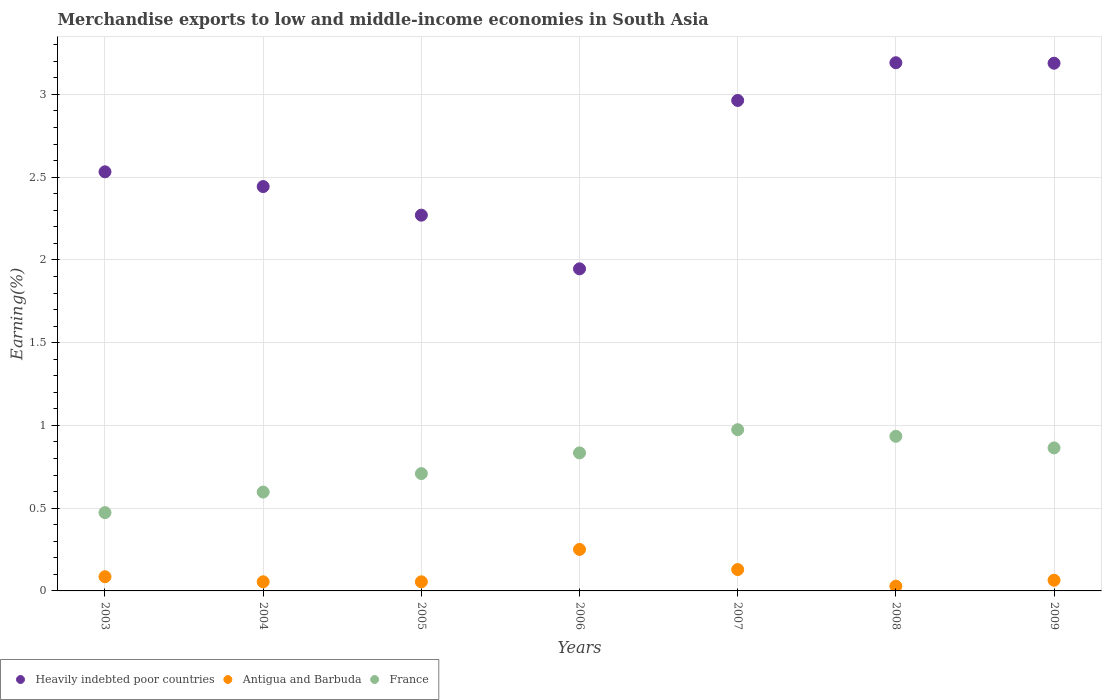How many different coloured dotlines are there?
Your answer should be compact. 3. Is the number of dotlines equal to the number of legend labels?
Your answer should be very brief. Yes. What is the percentage of amount earned from merchandise exports in Antigua and Barbuda in 2007?
Ensure brevity in your answer.  0.13. Across all years, what is the maximum percentage of amount earned from merchandise exports in Heavily indebted poor countries?
Ensure brevity in your answer.  3.19. Across all years, what is the minimum percentage of amount earned from merchandise exports in Antigua and Barbuda?
Provide a succinct answer. 0.03. In which year was the percentage of amount earned from merchandise exports in Antigua and Barbuda maximum?
Provide a succinct answer. 2006. In which year was the percentage of amount earned from merchandise exports in Heavily indebted poor countries minimum?
Offer a terse response. 2006. What is the total percentage of amount earned from merchandise exports in France in the graph?
Offer a very short reply. 5.39. What is the difference between the percentage of amount earned from merchandise exports in Antigua and Barbuda in 2004 and that in 2009?
Make the answer very short. -0.01. What is the difference between the percentage of amount earned from merchandise exports in France in 2004 and the percentage of amount earned from merchandise exports in Antigua and Barbuda in 2005?
Provide a short and direct response. 0.54. What is the average percentage of amount earned from merchandise exports in France per year?
Ensure brevity in your answer.  0.77. In the year 2006, what is the difference between the percentage of amount earned from merchandise exports in Heavily indebted poor countries and percentage of amount earned from merchandise exports in Antigua and Barbuda?
Offer a very short reply. 1.7. What is the ratio of the percentage of amount earned from merchandise exports in Antigua and Barbuda in 2003 to that in 2005?
Give a very brief answer. 1.56. Is the percentage of amount earned from merchandise exports in Heavily indebted poor countries in 2005 less than that in 2007?
Your response must be concise. Yes. Is the difference between the percentage of amount earned from merchandise exports in Heavily indebted poor countries in 2005 and 2007 greater than the difference between the percentage of amount earned from merchandise exports in Antigua and Barbuda in 2005 and 2007?
Offer a very short reply. No. What is the difference between the highest and the second highest percentage of amount earned from merchandise exports in Antigua and Barbuda?
Your answer should be very brief. 0.12. What is the difference between the highest and the lowest percentage of amount earned from merchandise exports in Heavily indebted poor countries?
Provide a short and direct response. 1.25. In how many years, is the percentage of amount earned from merchandise exports in Antigua and Barbuda greater than the average percentage of amount earned from merchandise exports in Antigua and Barbuda taken over all years?
Keep it short and to the point. 2. Is it the case that in every year, the sum of the percentage of amount earned from merchandise exports in Antigua and Barbuda and percentage of amount earned from merchandise exports in France  is greater than the percentage of amount earned from merchandise exports in Heavily indebted poor countries?
Your response must be concise. No. Is the percentage of amount earned from merchandise exports in Heavily indebted poor countries strictly greater than the percentage of amount earned from merchandise exports in France over the years?
Provide a short and direct response. Yes. How many dotlines are there?
Your response must be concise. 3. What is the difference between two consecutive major ticks on the Y-axis?
Provide a short and direct response. 0.5. Where does the legend appear in the graph?
Provide a short and direct response. Bottom left. How many legend labels are there?
Your answer should be compact. 3. What is the title of the graph?
Your answer should be compact. Merchandise exports to low and middle-income economies in South Asia. Does "Cayman Islands" appear as one of the legend labels in the graph?
Your answer should be compact. No. What is the label or title of the X-axis?
Provide a succinct answer. Years. What is the label or title of the Y-axis?
Offer a terse response. Earning(%). What is the Earning(%) in Heavily indebted poor countries in 2003?
Your answer should be compact. 2.53. What is the Earning(%) of Antigua and Barbuda in 2003?
Your answer should be compact. 0.09. What is the Earning(%) of France in 2003?
Offer a very short reply. 0.47. What is the Earning(%) in Heavily indebted poor countries in 2004?
Make the answer very short. 2.44. What is the Earning(%) in Antigua and Barbuda in 2004?
Your answer should be compact. 0.06. What is the Earning(%) of France in 2004?
Ensure brevity in your answer.  0.6. What is the Earning(%) of Heavily indebted poor countries in 2005?
Provide a short and direct response. 2.27. What is the Earning(%) in Antigua and Barbuda in 2005?
Keep it short and to the point. 0.06. What is the Earning(%) of France in 2005?
Your answer should be compact. 0.71. What is the Earning(%) of Heavily indebted poor countries in 2006?
Offer a terse response. 1.95. What is the Earning(%) of Antigua and Barbuda in 2006?
Your answer should be compact. 0.25. What is the Earning(%) of France in 2006?
Give a very brief answer. 0.83. What is the Earning(%) of Heavily indebted poor countries in 2007?
Keep it short and to the point. 2.96. What is the Earning(%) of Antigua and Barbuda in 2007?
Ensure brevity in your answer.  0.13. What is the Earning(%) in France in 2007?
Make the answer very short. 0.97. What is the Earning(%) of Heavily indebted poor countries in 2008?
Provide a short and direct response. 3.19. What is the Earning(%) of Antigua and Barbuda in 2008?
Your response must be concise. 0.03. What is the Earning(%) in France in 2008?
Provide a short and direct response. 0.93. What is the Earning(%) in Heavily indebted poor countries in 2009?
Make the answer very short. 3.19. What is the Earning(%) of Antigua and Barbuda in 2009?
Your answer should be compact. 0.06. What is the Earning(%) in France in 2009?
Offer a very short reply. 0.86. Across all years, what is the maximum Earning(%) of Heavily indebted poor countries?
Make the answer very short. 3.19. Across all years, what is the maximum Earning(%) in Antigua and Barbuda?
Provide a succinct answer. 0.25. Across all years, what is the maximum Earning(%) of France?
Your answer should be compact. 0.97. Across all years, what is the minimum Earning(%) in Heavily indebted poor countries?
Offer a very short reply. 1.95. Across all years, what is the minimum Earning(%) of Antigua and Barbuda?
Give a very brief answer. 0.03. Across all years, what is the minimum Earning(%) of France?
Your response must be concise. 0.47. What is the total Earning(%) in Heavily indebted poor countries in the graph?
Offer a very short reply. 18.54. What is the total Earning(%) of Antigua and Barbuda in the graph?
Your response must be concise. 0.67. What is the total Earning(%) of France in the graph?
Your answer should be very brief. 5.39. What is the difference between the Earning(%) in Heavily indebted poor countries in 2003 and that in 2004?
Your answer should be very brief. 0.09. What is the difference between the Earning(%) of Antigua and Barbuda in 2003 and that in 2004?
Your answer should be compact. 0.03. What is the difference between the Earning(%) in France in 2003 and that in 2004?
Your response must be concise. -0.12. What is the difference between the Earning(%) of Heavily indebted poor countries in 2003 and that in 2005?
Your answer should be very brief. 0.26. What is the difference between the Earning(%) of Antigua and Barbuda in 2003 and that in 2005?
Offer a terse response. 0.03. What is the difference between the Earning(%) of France in 2003 and that in 2005?
Your answer should be compact. -0.24. What is the difference between the Earning(%) of Heavily indebted poor countries in 2003 and that in 2006?
Your answer should be very brief. 0.59. What is the difference between the Earning(%) of Antigua and Barbuda in 2003 and that in 2006?
Keep it short and to the point. -0.17. What is the difference between the Earning(%) of France in 2003 and that in 2006?
Make the answer very short. -0.36. What is the difference between the Earning(%) in Heavily indebted poor countries in 2003 and that in 2007?
Your response must be concise. -0.43. What is the difference between the Earning(%) in Antigua and Barbuda in 2003 and that in 2007?
Provide a short and direct response. -0.04. What is the difference between the Earning(%) of France in 2003 and that in 2007?
Give a very brief answer. -0.5. What is the difference between the Earning(%) in Heavily indebted poor countries in 2003 and that in 2008?
Your answer should be very brief. -0.66. What is the difference between the Earning(%) of Antigua and Barbuda in 2003 and that in 2008?
Your answer should be compact. 0.06. What is the difference between the Earning(%) of France in 2003 and that in 2008?
Provide a short and direct response. -0.46. What is the difference between the Earning(%) in Heavily indebted poor countries in 2003 and that in 2009?
Keep it short and to the point. -0.66. What is the difference between the Earning(%) of Antigua and Barbuda in 2003 and that in 2009?
Offer a very short reply. 0.02. What is the difference between the Earning(%) in France in 2003 and that in 2009?
Offer a terse response. -0.39. What is the difference between the Earning(%) in Heavily indebted poor countries in 2004 and that in 2005?
Your answer should be compact. 0.17. What is the difference between the Earning(%) of Antigua and Barbuda in 2004 and that in 2005?
Your answer should be very brief. 0. What is the difference between the Earning(%) in France in 2004 and that in 2005?
Offer a terse response. -0.11. What is the difference between the Earning(%) of Heavily indebted poor countries in 2004 and that in 2006?
Give a very brief answer. 0.5. What is the difference between the Earning(%) in Antigua and Barbuda in 2004 and that in 2006?
Make the answer very short. -0.2. What is the difference between the Earning(%) of France in 2004 and that in 2006?
Offer a very short reply. -0.24. What is the difference between the Earning(%) of Heavily indebted poor countries in 2004 and that in 2007?
Keep it short and to the point. -0.52. What is the difference between the Earning(%) in Antigua and Barbuda in 2004 and that in 2007?
Provide a succinct answer. -0.07. What is the difference between the Earning(%) in France in 2004 and that in 2007?
Provide a short and direct response. -0.38. What is the difference between the Earning(%) of Heavily indebted poor countries in 2004 and that in 2008?
Make the answer very short. -0.75. What is the difference between the Earning(%) in Antigua and Barbuda in 2004 and that in 2008?
Your answer should be very brief. 0.03. What is the difference between the Earning(%) in France in 2004 and that in 2008?
Provide a succinct answer. -0.34. What is the difference between the Earning(%) in Heavily indebted poor countries in 2004 and that in 2009?
Your answer should be compact. -0.75. What is the difference between the Earning(%) of Antigua and Barbuda in 2004 and that in 2009?
Offer a terse response. -0.01. What is the difference between the Earning(%) of France in 2004 and that in 2009?
Provide a short and direct response. -0.27. What is the difference between the Earning(%) in Heavily indebted poor countries in 2005 and that in 2006?
Ensure brevity in your answer.  0.32. What is the difference between the Earning(%) of Antigua and Barbuda in 2005 and that in 2006?
Provide a short and direct response. -0.2. What is the difference between the Earning(%) of France in 2005 and that in 2006?
Ensure brevity in your answer.  -0.13. What is the difference between the Earning(%) of Heavily indebted poor countries in 2005 and that in 2007?
Give a very brief answer. -0.69. What is the difference between the Earning(%) in Antigua and Barbuda in 2005 and that in 2007?
Your answer should be compact. -0.07. What is the difference between the Earning(%) of France in 2005 and that in 2007?
Offer a very short reply. -0.27. What is the difference between the Earning(%) of Heavily indebted poor countries in 2005 and that in 2008?
Give a very brief answer. -0.92. What is the difference between the Earning(%) in Antigua and Barbuda in 2005 and that in 2008?
Keep it short and to the point. 0.03. What is the difference between the Earning(%) in France in 2005 and that in 2008?
Provide a succinct answer. -0.23. What is the difference between the Earning(%) of Heavily indebted poor countries in 2005 and that in 2009?
Offer a very short reply. -0.92. What is the difference between the Earning(%) in Antigua and Barbuda in 2005 and that in 2009?
Your answer should be very brief. -0.01. What is the difference between the Earning(%) in France in 2005 and that in 2009?
Offer a terse response. -0.16. What is the difference between the Earning(%) in Heavily indebted poor countries in 2006 and that in 2007?
Make the answer very short. -1.02. What is the difference between the Earning(%) in Antigua and Barbuda in 2006 and that in 2007?
Offer a very short reply. 0.12. What is the difference between the Earning(%) in France in 2006 and that in 2007?
Your answer should be compact. -0.14. What is the difference between the Earning(%) in Heavily indebted poor countries in 2006 and that in 2008?
Keep it short and to the point. -1.25. What is the difference between the Earning(%) of Antigua and Barbuda in 2006 and that in 2008?
Ensure brevity in your answer.  0.22. What is the difference between the Earning(%) in France in 2006 and that in 2008?
Offer a very short reply. -0.1. What is the difference between the Earning(%) in Heavily indebted poor countries in 2006 and that in 2009?
Make the answer very short. -1.24. What is the difference between the Earning(%) in Antigua and Barbuda in 2006 and that in 2009?
Offer a very short reply. 0.19. What is the difference between the Earning(%) in France in 2006 and that in 2009?
Provide a short and direct response. -0.03. What is the difference between the Earning(%) of Heavily indebted poor countries in 2007 and that in 2008?
Give a very brief answer. -0.23. What is the difference between the Earning(%) in Antigua and Barbuda in 2007 and that in 2008?
Your response must be concise. 0.1. What is the difference between the Earning(%) in France in 2007 and that in 2008?
Provide a succinct answer. 0.04. What is the difference between the Earning(%) of Heavily indebted poor countries in 2007 and that in 2009?
Make the answer very short. -0.23. What is the difference between the Earning(%) of Antigua and Barbuda in 2007 and that in 2009?
Your answer should be compact. 0.06. What is the difference between the Earning(%) of France in 2007 and that in 2009?
Ensure brevity in your answer.  0.11. What is the difference between the Earning(%) in Heavily indebted poor countries in 2008 and that in 2009?
Provide a short and direct response. 0. What is the difference between the Earning(%) in Antigua and Barbuda in 2008 and that in 2009?
Provide a succinct answer. -0.04. What is the difference between the Earning(%) in France in 2008 and that in 2009?
Your answer should be compact. 0.07. What is the difference between the Earning(%) of Heavily indebted poor countries in 2003 and the Earning(%) of Antigua and Barbuda in 2004?
Offer a terse response. 2.48. What is the difference between the Earning(%) of Heavily indebted poor countries in 2003 and the Earning(%) of France in 2004?
Give a very brief answer. 1.94. What is the difference between the Earning(%) of Antigua and Barbuda in 2003 and the Earning(%) of France in 2004?
Your response must be concise. -0.51. What is the difference between the Earning(%) of Heavily indebted poor countries in 2003 and the Earning(%) of Antigua and Barbuda in 2005?
Keep it short and to the point. 2.48. What is the difference between the Earning(%) in Heavily indebted poor countries in 2003 and the Earning(%) in France in 2005?
Make the answer very short. 1.82. What is the difference between the Earning(%) of Antigua and Barbuda in 2003 and the Earning(%) of France in 2005?
Your answer should be compact. -0.62. What is the difference between the Earning(%) in Heavily indebted poor countries in 2003 and the Earning(%) in Antigua and Barbuda in 2006?
Your answer should be compact. 2.28. What is the difference between the Earning(%) of Heavily indebted poor countries in 2003 and the Earning(%) of France in 2006?
Offer a terse response. 1.7. What is the difference between the Earning(%) in Antigua and Barbuda in 2003 and the Earning(%) in France in 2006?
Offer a very short reply. -0.75. What is the difference between the Earning(%) in Heavily indebted poor countries in 2003 and the Earning(%) in Antigua and Barbuda in 2007?
Provide a short and direct response. 2.4. What is the difference between the Earning(%) in Heavily indebted poor countries in 2003 and the Earning(%) in France in 2007?
Provide a succinct answer. 1.56. What is the difference between the Earning(%) in Antigua and Barbuda in 2003 and the Earning(%) in France in 2007?
Ensure brevity in your answer.  -0.89. What is the difference between the Earning(%) of Heavily indebted poor countries in 2003 and the Earning(%) of Antigua and Barbuda in 2008?
Your answer should be very brief. 2.5. What is the difference between the Earning(%) of Heavily indebted poor countries in 2003 and the Earning(%) of France in 2008?
Provide a succinct answer. 1.6. What is the difference between the Earning(%) of Antigua and Barbuda in 2003 and the Earning(%) of France in 2008?
Provide a short and direct response. -0.85. What is the difference between the Earning(%) in Heavily indebted poor countries in 2003 and the Earning(%) in Antigua and Barbuda in 2009?
Offer a terse response. 2.47. What is the difference between the Earning(%) of Heavily indebted poor countries in 2003 and the Earning(%) of France in 2009?
Your answer should be compact. 1.67. What is the difference between the Earning(%) in Antigua and Barbuda in 2003 and the Earning(%) in France in 2009?
Provide a succinct answer. -0.78. What is the difference between the Earning(%) of Heavily indebted poor countries in 2004 and the Earning(%) of Antigua and Barbuda in 2005?
Provide a short and direct response. 2.39. What is the difference between the Earning(%) in Heavily indebted poor countries in 2004 and the Earning(%) in France in 2005?
Your answer should be compact. 1.73. What is the difference between the Earning(%) of Antigua and Barbuda in 2004 and the Earning(%) of France in 2005?
Make the answer very short. -0.65. What is the difference between the Earning(%) of Heavily indebted poor countries in 2004 and the Earning(%) of Antigua and Barbuda in 2006?
Make the answer very short. 2.19. What is the difference between the Earning(%) in Heavily indebted poor countries in 2004 and the Earning(%) in France in 2006?
Your response must be concise. 1.61. What is the difference between the Earning(%) of Antigua and Barbuda in 2004 and the Earning(%) of France in 2006?
Your response must be concise. -0.78. What is the difference between the Earning(%) in Heavily indebted poor countries in 2004 and the Earning(%) in Antigua and Barbuda in 2007?
Ensure brevity in your answer.  2.31. What is the difference between the Earning(%) of Heavily indebted poor countries in 2004 and the Earning(%) of France in 2007?
Provide a succinct answer. 1.47. What is the difference between the Earning(%) in Antigua and Barbuda in 2004 and the Earning(%) in France in 2007?
Keep it short and to the point. -0.92. What is the difference between the Earning(%) of Heavily indebted poor countries in 2004 and the Earning(%) of Antigua and Barbuda in 2008?
Your answer should be very brief. 2.41. What is the difference between the Earning(%) in Heavily indebted poor countries in 2004 and the Earning(%) in France in 2008?
Provide a succinct answer. 1.51. What is the difference between the Earning(%) in Antigua and Barbuda in 2004 and the Earning(%) in France in 2008?
Provide a succinct answer. -0.88. What is the difference between the Earning(%) of Heavily indebted poor countries in 2004 and the Earning(%) of Antigua and Barbuda in 2009?
Offer a terse response. 2.38. What is the difference between the Earning(%) in Heavily indebted poor countries in 2004 and the Earning(%) in France in 2009?
Your answer should be very brief. 1.58. What is the difference between the Earning(%) in Antigua and Barbuda in 2004 and the Earning(%) in France in 2009?
Make the answer very short. -0.81. What is the difference between the Earning(%) of Heavily indebted poor countries in 2005 and the Earning(%) of Antigua and Barbuda in 2006?
Offer a terse response. 2.02. What is the difference between the Earning(%) in Heavily indebted poor countries in 2005 and the Earning(%) in France in 2006?
Give a very brief answer. 1.44. What is the difference between the Earning(%) of Antigua and Barbuda in 2005 and the Earning(%) of France in 2006?
Your response must be concise. -0.78. What is the difference between the Earning(%) of Heavily indebted poor countries in 2005 and the Earning(%) of Antigua and Barbuda in 2007?
Ensure brevity in your answer.  2.14. What is the difference between the Earning(%) in Heavily indebted poor countries in 2005 and the Earning(%) in France in 2007?
Provide a succinct answer. 1.3. What is the difference between the Earning(%) of Antigua and Barbuda in 2005 and the Earning(%) of France in 2007?
Offer a terse response. -0.92. What is the difference between the Earning(%) of Heavily indebted poor countries in 2005 and the Earning(%) of Antigua and Barbuda in 2008?
Provide a succinct answer. 2.24. What is the difference between the Earning(%) of Heavily indebted poor countries in 2005 and the Earning(%) of France in 2008?
Ensure brevity in your answer.  1.34. What is the difference between the Earning(%) in Antigua and Barbuda in 2005 and the Earning(%) in France in 2008?
Give a very brief answer. -0.88. What is the difference between the Earning(%) in Heavily indebted poor countries in 2005 and the Earning(%) in Antigua and Barbuda in 2009?
Your answer should be compact. 2.21. What is the difference between the Earning(%) in Heavily indebted poor countries in 2005 and the Earning(%) in France in 2009?
Give a very brief answer. 1.41. What is the difference between the Earning(%) of Antigua and Barbuda in 2005 and the Earning(%) of France in 2009?
Keep it short and to the point. -0.81. What is the difference between the Earning(%) in Heavily indebted poor countries in 2006 and the Earning(%) in Antigua and Barbuda in 2007?
Ensure brevity in your answer.  1.82. What is the difference between the Earning(%) of Antigua and Barbuda in 2006 and the Earning(%) of France in 2007?
Your response must be concise. -0.72. What is the difference between the Earning(%) of Heavily indebted poor countries in 2006 and the Earning(%) of Antigua and Barbuda in 2008?
Your response must be concise. 1.92. What is the difference between the Earning(%) in Antigua and Barbuda in 2006 and the Earning(%) in France in 2008?
Your response must be concise. -0.68. What is the difference between the Earning(%) of Heavily indebted poor countries in 2006 and the Earning(%) of Antigua and Barbuda in 2009?
Keep it short and to the point. 1.88. What is the difference between the Earning(%) of Heavily indebted poor countries in 2006 and the Earning(%) of France in 2009?
Your answer should be compact. 1.08. What is the difference between the Earning(%) in Antigua and Barbuda in 2006 and the Earning(%) in France in 2009?
Your answer should be very brief. -0.61. What is the difference between the Earning(%) in Heavily indebted poor countries in 2007 and the Earning(%) in Antigua and Barbuda in 2008?
Offer a terse response. 2.93. What is the difference between the Earning(%) in Heavily indebted poor countries in 2007 and the Earning(%) in France in 2008?
Make the answer very short. 2.03. What is the difference between the Earning(%) of Antigua and Barbuda in 2007 and the Earning(%) of France in 2008?
Your answer should be compact. -0.81. What is the difference between the Earning(%) in Heavily indebted poor countries in 2007 and the Earning(%) in Antigua and Barbuda in 2009?
Offer a very short reply. 2.9. What is the difference between the Earning(%) of Heavily indebted poor countries in 2007 and the Earning(%) of France in 2009?
Your response must be concise. 2.1. What is the difference between the Earning(%) in Antigua and Barbuda in 2007 and the Earning(%) in France in 2009?
Ensure brevity in your answer.  -0.73. What is the difference between the Earning(%) of Heavily indebted poor countries in 2008 and the Earning(%) of Antigua and Barbuda in 2009?
Provide a short and direct response. 3.13. What is the difference between the Earning(%) of Heavily indebted poor countries in 2008 and the Earning(%) of France in 2009?
Provide a succinct answer. 2.33. What is the difference between the Earning(%) in Antigua and Barbuda in 2008 and the Earning(%) in France in 2009?
Your answer should be very brief. -0.84. What is the average Earning(%) in Heavily indebted poor countries per year?
Provide a succinct answer. 2.65. What is the average Earning(%) in Antigua and Barbuda per year?
Give a very brief answer. 0.1. What is the average Earning(%) of France per year?
Your response must be concise. 0.77. In the year 2003, what is the difference between the Earning(%) of Heavily indebted poor countries and Earning(%) of Antigua and Barbuda?
Make the answer very short. 2.45. In the year 2003, what is the difference between the Earning(%) in Heavily indebted poor countries and Earning(%) in France?
Offer a very short reply. 2.06. In the year 2003, what is the difference between the Earning(%) of Antigua and Barbuda and Earning(%) of France?
Ensure brevity in your answer.  -0.39. In the year 2004, what is the difference between the Earning(%) in Heavily indebted poor countries and Earning(%) in Antigua and Barbuda?
Provide a succinct answer. 2.39. In the year 2004, what is the difference between the Earning(%) of Heavily indebted poor countries and Earning(%) of France?
Offer a terse response. 1.85. In the year 2004, what is the difference between the Earning(%) of Antigua and Barbuda and Earning(%) of France?
Offer a very short reply. -0.54. In the year 2005, what is the difference between the Earning(%) of Heavily indebted poor countries and Earning(%) of Antigua and Barbuda?
Provide a succinct answer. 2.22. In the year 2005, what is the difference between the Earning(%) of Heavily indebted poor countries and Earning(%) of France?
Ensure brevity in your answer.  1.56. In the year 2005, what is the difference between the Earning(%) of Antigua and Barbuda and Earning(%) of France?
Give a very brief answer. -0.65. In the year 2006, what is the difference between the Earning(%) of Heavily indebted poor countries and Earning(%) of Antigua and Barbuda?
Provide a short and direct response. 1.7. In the year 2006, what is the difference between the Earning(%) in Heavily indebted poor countries and Earning(%) in France?
Provide a succinct answer. 1.11. In the year 2006, what is the difference between the Earning(%) in Antigua and Barbuda and Earning(%) in France?
Your answer should be very brief. -0.58. In the year 2007, what is the difference between the Earning(%) in Heavily indebted poor countries and Earning(%) in Antigua and Barbuda?
Your response must be concise. 2.83. In the year 2007, what is the difference between the Earning(%) of Heavily indebted poor countries and Earning(%) of France?
Offer a very short reply. 1.99. In the year 2007, what is the difference between the Earning(%) in Antigua and Barbuda and Earning(%) in France?
Give a very brief answer. -0.85. In the year 2008, what is the difference between the Earning(%) of Heavily indebted poor countries and Earning(%) of Antigua and Barbuda?
Your answer should be compact. 3.16. In the year 2008, what is the difference between the Earning(%) in Heavily indebted poor countries and Earning(%) in France?
Your answer should be very brief. 2.26. In the year 2008, what is the difference between the Earning(%) of Antigua and Barbuda and Earning(%) of France?
Offer a very short reply. -0.91. In the year 2009, what is the difference between the Earning(%) of Heavily indebted poor countries and Earning(%) of Antigua and Barbuda?
Offer a terse response. 3.12. In the year 2009, what is the difference between the Earning(%) of Heavily indebted poor countries and Earning(%) of France?
Provide a short and direct response. 2.32. In the year 2009, what is the difference between the Earning(%) of Antigua and Barbuda and Earning(%) of France?
Keep it short and to the point. -0.8. What is the ratio of the Earning(%) in Heavily indebted poor countries in 2003 to that in 2004?
Give a very brief answer. 1.04. What is the ratio of the Earning(%) in Antigua and Barbuda in 2003 to that in 2004?
Keep it short and to the point. 1.55. What is the ratio of the Earning(%) of France in 2003 to that in 2004?
Your answer should be very brief. 0.79. What is the ratio of the Earning(%) of Heavily indebted poor countries in 2003 to that in 2005?
Offer a very short reply. 1.12. What is the ratio of the Earning(%) of Antigua and Barbuda in 2003 to that in 2005?
Offer a very short reply. 1.56. What is the ratio of the Earning(%) in France in 2003 to that in 2005?
Your answer should be compact. 0.67. What is the ratio of the Earning(%) of Heavily indebted poor countries in 2003 to that in 2006?
Provide a short and direct response. 1.3. What is the ratio of the Earning(%) of Antigua and Barbuda in 2003 to that in 2006?
Offer a terse response. 0.34. What is the ratio of the Earning(%) in France in 2003 to that in 2006?
Keep it short and to the point. 0.57. What is the ratio of the Earning(%) in Heavily indebted poor countries in 2003 to that in 2007?
Ensure brevity in your answer.  0.85. What is the ratio of the Earning(%) of Antigua and Barbuda in 2003 to that in 2007?
Make the answer very short. 0.66. What is the ratio of the Earning(%) in France in 2003 to that in 2007?
Your answer should be very brief. 0.49. What is the ratio of the Earning(%) in Heavily indebted poor countries in 2003 to that in 2008?
Your response must be concise. 0.79. What is the ratio of the Earning(%) of Antigua and Barbuda in 2003 to that in 2008?
Your answer should be very brief. 2.98. What is the ratio of the Earning(%) of France in 2003 to that in 2008?
Give a very brief answer. 0.51. What is the ratio of the Earning(%) in Heavily indebted poor countries in 2003 to that in 2009?
Ensure brevity in your answer.  0.79. What is the ratio of the Earning(%) in Antigua and Barbuda in 2003 to that in 2009?
Provide a succinct answer. 1.33. What is the ratio of the Earning(%) in France in 2003 to that in 2009?
Offer a terse response. 0.55. What is the ratio of the Earning(%) of Heavily indebted poor countries in 2004 to that in 2005?
Give a very brief answer. 1.08. What is the ratio of the Earning(%) in Antigua and Barbuda in 2004 to that in 2005?
Ensure brevity in your answer.  1. What is the ratio of the Earning(%) in France in 2004 to that in 2005?
Give a very brief answer. 0.84. What is the ratio of the Earning(%) of Heavily indebted poor countries in 2004 to that in 2006?
Provide a succinct answer. 1.26. What is the ratio of the Earning(%) in Antigua and Barbuda in 2004 to that in 2006?
Make the answer very short. 0.22. What is the ratio of the Earning(%) in France in 2004 to that in 2006?
Offer a terse response. 0.72. What is the ratio of the Earning(%) in Heavily indebted poor countries in 2004 to that in 2007?
Provide a succinct answer. 0.82. What is the ratio of the Earning(%) in Antigua and Barbuda in 2004 to that in 2007?
Provide a short and direct response. 0.43. What is the ratio of the Earning(%) in France in 2004 to that in 2007?
Offer a terse response. 0.61. What is the ratio of the Earning(%) in Heavily indebted poor countries in 2004 to that in 2008?
Your response must be concise. 0.77. What is the ratio of the Earning(%) in Antigua and Barbuda in 2004 to that in 2008?
Provide a succinct answer. 1.91. What is the ratio of the Earning(%) in France in 2004 to that in 2008?
Offer a terse response. 0.64. What is the ratio of the Earning(%) in Heavily indebted poor countries in 2004 to that in 2009?
Provide a succinct answer. 0.77. What is the ratio of the Earning(%) of Antigua and Barbuda in 2004 to that in 2009?
Provide a short and direct response. 0.86. What is the ratio of the Earning(%) in France in 2004 to that in 2009?
Keep it short and to the point. 0.69. What is the ratio of the Earning(%) in Heavily indebted poor countries in 2005 to that in 2006?
Your response must be concise. 1.17. What is the ratio of the Earning(%) of Antigua and Barbuda in 2005 to that in 2006?
Your answer should be compact. 0.22. What is the ratio of the Earning(%) in France in 2005 to that in 2006?
Keep it short and to the point. 0.85. What is the ratio of the Earning(%) in Heavily indebted poor countries in 2005 to that in 2007?
Your answer should be compact. 0.77. What is the ratio of the Earning(%) of Antigua and Barbuda in 2005 to that in 2007?
Make the answer very short. 0.43. What is the ratio of the Earning(%) in France in 2005 to that in 2007?
Provide a succinct answer. 0.73. What is the ratio of the Earning(%) in Heavily indebted poor countries in 2005 to that in 2008?
Provide a short and direct response. 0.71. What is the ratio of the Earning(%) of Antigua and Barbuda in 2005 to that in 2008?
Give a very brief answer. 1.91. What is the ratio of the Earning(%) in France in 2005 to that in 2008?
Your answer should be very brief. 0.76. What is the ratio of the Earning(%) in Heavily indebted poor countries in 2005 to that in 2009?
Your response must be concise. 0.71. What is the ratio of the Earning(%) in Antigua and Barbuda in 2005 to that in 2009?
Make the answer very short. 0.85. What is the ratio of the Earning(%) in France in 2005 to that in 2009?
Ensure brevity in your answer.  0.82. What is the ratio of the Earning(%) of Heavily indebted poor countries in 2006 to that in 2007?
Make the answer very short. 0.66. What is the ratio of the Earning(%) of Antigua and Barbuda in 2006 to that in 2007?
Provide a short and direct response. 1.94. What is the ratio of the Earning(%) in France in 2006 to that in 2007?
Offer a terse response. 0.86. What is the ratio of the Earning(%) of Heavily indebted poor countries in 2006 to that in 2008?
Ensure brevity in your answer.  0.61. What is the ratio of the Earning(%) in Antigua and Barbuda in 2006 to that in 2008?
Give a very brief answer. 8.7. What is the ratio of the Earning(%) in France in 2006 to that in 2008?
Give a very brief answer. 0.89. What is the ratio of the Earning(%) of Heavily indebted poor countries in 2006 to that in 2009?
Offer a very short reply. 0.61. What is the ratio of the Earning(%) of Antigua and Barbuda in 2006 to that in 2009?
Keep it short and to the point. 3.89. What is the ratio of the Earning(%) of France in 2006 to that in 2009?
Your response must be concise. 0.97. What is the ratio of the Earning(%) in Antigua and Barbuda in 2007 to that in 2008?
Give a very brief answer. 4.48. What is the ratio of the Earning(%) in France in 2007 to that in 2008?
Your answer should be very brief. 1.04. What is the ratio of the Earning(%) of Heavily indebted poor countries in 2007 to that in 2009?
Make the answer very short. 0.93. What is the ratio of the Earning(%) in Antigua and Barbuda in 2007 to that in 2009?
Make the answer very short. 2. What is the ratio of the Earning(%) of France in 2007 to that in 2009?
Your answer should be compact. 1.13. What is the ratio of the Earning(%) in Heavily indebted poor countries in 2008 to that in 2009?
Provide a short and direct response. 1. What is the ratio of the Earning(%) of Antigua and Barbuda in 2008 to that in 2009?
Make the answer very short. 0.45. What is the ratio of the Earning(%) in France in 2008 to that in 2009?
Your answer should be compact. 1.08. What is the difference between the highest and the second highest Earning(%) of Heavily indebted poor countries?
Make the answer very short. 0. What is the difference between the highest and the second highest Earning(%) of Antigua and Barbuda?
Give a very brief answer. 0.12. What is the difference between the highest and the lowest Earning(%) of Heavily indebted poor countries?
Keep it short and to the point. 1.25. What is the difference between the highest and the lowest Earning(%) of Antigua and Barbuda?
Provide a short and direct response. 0.22. What is the difference between the highest and the lowest Earning(%) of France?
Make the answer very short. 0.5. 